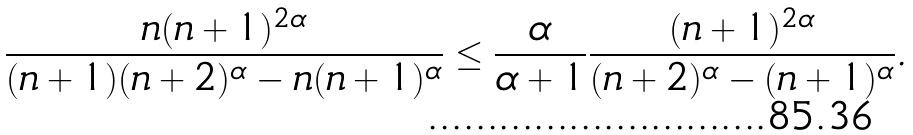Convert formula to latex. <formula><loc_0><loc_0><loc_500><loc_500>\frac { n ( n + 1 ) ^ { 2 \alpha } } { ( n + 1 ) ( n + 2 ) ^ { \alpha } - n ( n + 1 ) ^ { \alpha } } \leq \frac { \alpha } { \alpha + 1 } \frac { ( n + 1 ) ^ { 2 \alpha } } { ( n + 2 ) ^ { \alpha } - ( n + 1 ) ^ { \alpha } } .</formula> 